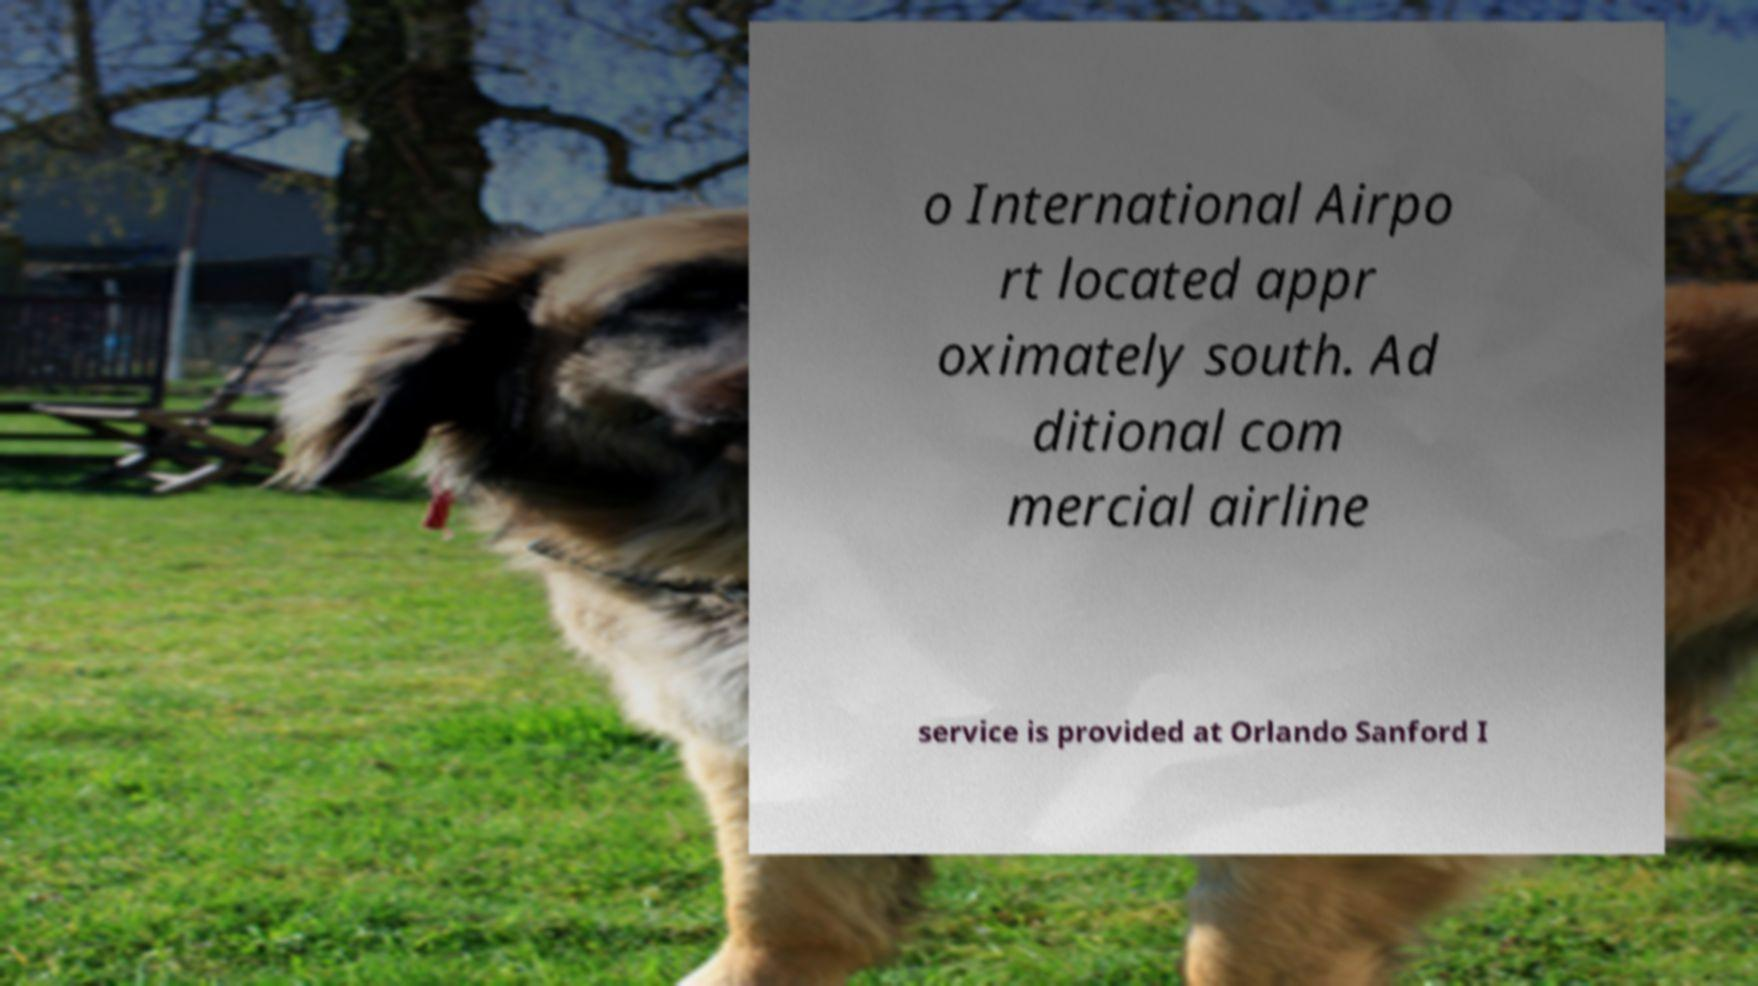I need the written content from this picture converted into text. Can you do that? o International Airpo rt located appr oximately south. Ad ditional com mercial airline service is provided at Orlando Sanford I 